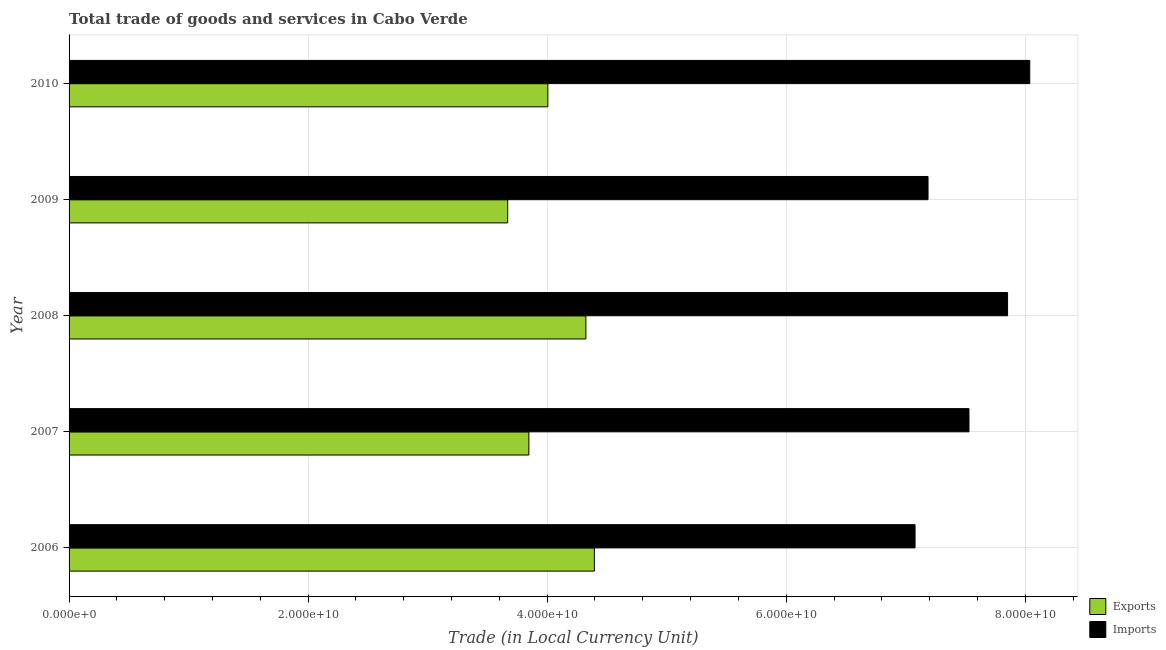How many different coloured bars are there?
Your answer should be compact. 2. How many groups of bars are there?
Ensure brevity in your answer.  5. Are the number of bars per tick equal to the number of legend labels?
Give a very brief answer. Yes. In how many cases, is the number of bars for a given year not equal to the number of legend labels?
Give a very brief answer. 0. What is the export of goods and services in 2007?
Provide a short and direct response. 3.85e+1. Across all years, what is the maximum export of goods and services?
Keep it short and to the point. 4.40e+1. Across all years, what is the minimum export of goods and services?
Provide a succinct answer. 3.67e+1. In which year was the imports of goods and services minimum?
Offer a very short reply. 2006. What is the total imports of goods and services in the graph?
Provide a short and direct response. 3.77e+11. What is the difference between the imports of goods and services in 2007 and that in 2009?
Offer a terse response. 3.43e+09. What is the difference between the export of goods and services in 2009 and the imports of goods and services in 2010?
Give a very brief answer. -4.37e+1. What is the average imports of goods and services per year?
Your answer should be compact. 7.54e+1. In the year 2009, what is the difference between the export of goods and services and imports of goods and services?
Offer a terse response. -3.52e+1. What is the ratio of the export of goods and services in 2006 to that in 2009?
Ensure brevity in your answer.  1.2. What is the difference between the highest and the second highest export of goods and services?
Keep it short and to the point. 7.10e+08. What is the difference between the highest and the lowest imports of goods and services?
Provide a succinct answer. 9.60e+09. What does the 2nd bar from the top in 2007 represents?
Your answer should be very brief. Exports. What does the 1st bar from the bottom in 2008 represents?
Keep it short and to the point. Exports. How many bars are there?
Provide a short and direct response. 10. What is the difference between two consecutive major ticks on the X-axis?
Give a very brief answer. 2.00e+1. Are the values on the major ticks of X-axis written in scientific E-notation?
Give a very brief answer. Yes. Does the graph contain any zero values?
Provide a short and direct response. No. Where does the legend appear in the graph?
Your answer should be compact. Bottom right. How many legend labels are there?
Keep it short and to the point. 2. How are the legend labels stacked?
Offer a terse response. Vertical. What is the title of the graph?
Your answer should be compact. Total trade of goods and services in Cabo Verde. Does "Ages 15-24" appear as one of the legend labels in the graph?
Keep it short and to the point. No. What is the label or title of the X-axis?
Your answer should be compact. Trade (in Local Currency Unit). What is the Trade (in Local Currency Unit) of Exports in 2006?
Your response must be concise. 4.40e+1. What is the Trade (in Local Currency Unit) in Imports in 2006?
Your response must be concise. 7.08e+1. What is the Trade (in Local Currency Unit) in Exports in 2007?
Your answer should be very brief. 3.85e+1. What is the Trade (in Local Currency Unit) in Imports in 2007?
Your answer should be compact. 7.53e+1. What is the Trade (in Local Currency Unit) of Exports in 2008?
Keep it short and to the point. 4.32e+1. What is the Trade (in Local Currency Unit) of Imports in 2008?
Give a very brief answer. 7.85e+1. What is the Trade (in Local Currency Unit) of Exports in 2009?
Offer a very short reply. 3.67e+1. What is the Trade (in Local Currency Unit) in Imports in 2009?
Your answer should be compact. 7.19e+1. What is the Trade (in Local Currency Unit) in Exports in 2010?
Your answer should be compact. 4.01e+1. What is the Trade (in Local Currency Unit) in Imports in 2010?
Provide a short and direct response. 8.04e+1. Across all years, what is the maximum Trade (in Local Currency Unit) of Exports?
Keep it short and to the point. 4.40e+1. Across all years, what is the maximum Trade (in Local Currency Unit) in Imports?
Provide a succinct answer. 8.04e+1. Across all years, what is the minimum Trade (in Local Currency Unit) in Exports?
Provide a short and direct response. 3.67e+1. Across all years, what is the minimum Trade (in Local Currency Unit) of Imports?
Offer a very short reply. 7.08e+1. What is the total Trade (in Local Currency Unit) in Exports in the graph?
Offer a very short reply. 2.02e+11. What is the total Trade (in Local Currency Unit) of Imports in the graph?
Your response must be concise. 3.77e+11. What is the difference between the Trade (in Local Currency Unit) in Exports in 2006 and that in 2007?
Provide a succinct answer. 5.48e+09. What is the difference between the Trade (in Local Currency Unit) in Imports in 2006 and that in 2007?
Provide a succinct answer. -4.51e+09. What is the difference between the Trade (in Local Currency Unit) of Exports in 2006 and that in 2008?
Your response must be concise. 7.10e+08. What is the difference between the Trade (in Local Currency Unit) in Imports in 2006 and that in 2008?
Make the answer very short. -7.74e+09. What is the difference between the Trade (in Local Currency Unit) of Exports in 2006 and that in 2009?
Your response must be concise. 7.25e+09. What is the difference between the Trade (in Local Currency Unit) in Imports in 2006 and that in 2009?
Provide a succinct answer. -1.08e+09. What is the difference between the Trade (in Local Currency Unit) in Exports in 2006 and that in 2010?
Keep it short and to the point. 3.89e+09. What is the difference between the Trade (in Local Currency Unit) in Imports in 2006 and that in 2010?
Keep it short and to the point. -9.60e+09. What is the difference between the Trade (in Local Currency Unit) of Exports in 2007 and that in 2008?
Provide a succinct answer. -4.77e+09. What is the difference between the Trade (in Local Currency Unit) in Imports in 2007 and that in 2008?
Make the answer very short. -3.23e+09. What is the difference between the Trade (in Local Currency Unit) in Exports in 2007 and that in 2009?
Keep it short and to the point. 1.77e+09. What is the difference between the Trade (in Local Currency Unit) in Imports in 2007 and that in 2009?
Offer a very short reply. 3.43e+09. What is the difference between the Trade (in Local Currency Unit) of Exports in 2007 and that in 2010?
Offer a very short reply. -1.59e+09. What is the difference between the Trade (in Local Currency Unit) in Imports in 2007 and that in 2010?
Ensure brevity in your answer.  -5.09e+09. What is the difference between the Trade (in Local Currency Unit) in Exports in 2008 and that in 2009?
Provide a short and direct response. 6.54e+09. What is the difference between the Trade (in Local Currency Unit) in Imports in 2008 and that in 2009?
Keep it short and to the point. 6.66e+09. What is the difference between the Trade (in Local Currency Unit) of Exports in 2008 and that in 2010?
Your response must be concise. 3.18e+09. What is the difference between the Trade (in Local Currency Unit) of Imports in 2008 and that in 2010?
Your answer should be very brief. -1.86e+09. What is the difference between the Trade (in Local Currency Unit) in Exports in 2009 and that in 2010?
Your response must be concise. -3.36e+09. What is the difference between the Trade (in Local Currency Unit) of Imports in 2009 and that in 2010?
Offer a terse response. -8.51e+09. What is the difference between the Trade (in Local Currency Unit) in Exports in 2006 and the Trade (in Local Currency Unit) in Imports in 2007?
Make the answer very short. -3.13e+1. What is the difference between the Trade (in Local Currency Unit) of Exports in 2006 and the Trade (in Local Currency Unit) of Imports in 2008?
Offer a very short reply. -3.46e+1. What is the difference between the Trade (in Local Currency Unit) of Exports in 2006 and the Trade (in Local Currency Unit) of Imports in 2009?
Keep it short and to the point. -2.79e+1. What is the difference between the Trade (in Local Currency Unit) in Exports in 2006 and the Trade (in Local Currency Unit) in Imports in 2010?
Make the answer very short. -3.64e+1. What is the difference between the Trade (in Local Currency Unit) of Exports in 2007 and the Trade (in Local Currency Unit) of Imports in 2008?
Give a very brief answer. -4.01e+1. What is the difference between the Trade (in Local Currency Unit) of Exports in 2007 and the Trade (in Local Currency Unit) of Imports in 2009?
Your answer should be very brief. -3.34e+1. What is the difference between the Trade (in Local Currency Unit) in Exports in 2007 and the Trade (in Local Currency Unit) in Imports in 2010?
Keep it short and to the point. -4.19e+1. What is the difference between the Trade (in Local Currency Unit) of Exports in 2008 and the Trade (in Local Currency Unit) of Imports in 2009?
Provide a short and direct response. -2.86e+1. What is the difference between the Trade (in Local Currency Unit) of Exports in 2008 and the Trade (in Local Currency Unit) of Imports in 2010?
Give a very brief answer. -3.71e+1. What is the difference between the Trade (in Local Currency Unit) in Exports in 2009 and the Trade (in Local Currency Unit) in Imports in 2010?
Provide a short and direct response. -4.37e+1. What is the average Trade (in Local Currency Unit) of Exports per year?
Offer a very short reply. 4.05e+1. What is the average Trade (in Local Currency Unit) of Imports per year?
Make the answer very short. 7.54e+1. In the year 2006, what is the difference between the Trade (in Local Currency Unit) in Exports and Trade (in Local Currency Unit) in Imports?
Provide a succinct answer. -2.68e+1. In the year 2007, what is the difference between the Trade (in Local Currency Unit) in Exports and Trade (in Local Currency Unit) in Imports?
Your answer should be compact. -3.68e+1. In the year 2008, what is the difference between the Trade (in Local Currency Unit) of Exports and Trade (in Local Currency Unit) of Imports?
Provide a short and direct response. -3.53e+1. In the year 2009, what is the difference between the Trade (in Local Currency Unit) in Exports and Trade (in Local Currency Unit) in Imports?
Make the answer very short. -3.52e+1. In the year 2010, what is the difference between the Trade (in Local Currency Unit) in Exports and Trade (in Local Currency Unit) in Imports?
Give a very brief answer. -4.03e+1. What is the ratio of the Trade (in Local Currency Unit) of Exports in 2006 to that in 2007?
Ensure brevity in your answer.  1.14. What is the ratio of the Trade (in Local Currency Unit) of Imports in 2006 to that in 2007?
Offer a terse response. 0.94. What is the ratio of the Trade (in Local Currency Unit) of Exports in 2006 to that in 2008?
Your answer should be very brief. 1.02. What is the ratio of the Trade (in Local Currency Unit) in Imports in 2006 to that in 2008?
Your response must be concise. 0.9. What is the ratio of the Trade (in Local Currency Unit) in Exports in 2006 to that in 2009?
Make the answer very short. 1.2. What is the ratio of the Trade (in Local Currency Unit) in Imports in 2006 to that in 2009?
Your answer should be compact. 0.98. What is the ratio of the Trade (in Local Currency Unit) of Exports in 2006 to that in 2010?
Your answer should be compact. 1.1. What is the ratio of the Trade (in Local Currency Unit) in Imports in 2006 to that in 2010?
Offer a very short reply. 0.88. What is the ratio of the Trade (in Local Currency Unit) in Exports in 2007 to that in 2008?
Offer a terse response. 0.89. What is the ratio of the Trade (in Local Currency Unit) of Imports in 2007 to that in 2008?
Give a very brief answer. 0.96. What is the ratio of the Trade (in Local Currency Unit) of Exports in 2007 to that in 2009?
Keep it short and to the point. 1.05. What is the ratio of the Trade (in Local Currency Unit) of Imports in 2007 to that in 2009?
Make the answer very short. 1.05. What is the ratio of the Trade (in Local Currency Unit) of Exports in 2007 to that in 2010?
Your response must be concise. 0.96. What is the ratio of the Trade (in Local Currency Unit) in Imports in 2007 to that in 2010?
Keep it short and to the point. 0.94. What is the ratio of the Trade (in Local Currency Unit) in Exports in 2008 to that in 2009?
Provide a succinct answer. 1.18. What is the ratio of the Trade (in Local Currency Unit) of Imports in 2008 to that in 2009?
Offer a very short reply. 1.09. What is the ratio of the Trade (in Local Currency Unit) in Exports in 2008 to that in 2010?
Offer a very short reply. 1.08. What is the ratio of the Trade (in Local Currency Unit) of Imports in 2008 to that in 2010?
Offer a terse response. 0.98. What is the ratio of the Trade (in Local Currency Unit) of Exports in 2009 to that in 2010?
Provide a succinct answer. 0.92. What is the ratio of the Trade (in Local Currency Unit) in Imports in 2009 to that in 2010?
Make the answer very short. 0.89. What is the difference between the highest and the second highest Trade (in Local Currency Unit) of Exports?
Your response must be concise. 7.10e+08. What is the difference between the highest and the second highest Trade (in Local Currency Unit) in Imports?
Your answer should be very brief. 1.86e+09. What is the difference between the highest and the lowest Trade (in Local Currency Unit) of Exports?
Your response must be concise. 7.25e+09. What is the difference between the highest and the lowest Trade (in Local Currency Unit) of Imports?
Your response must be concise. 9.60e+09. 